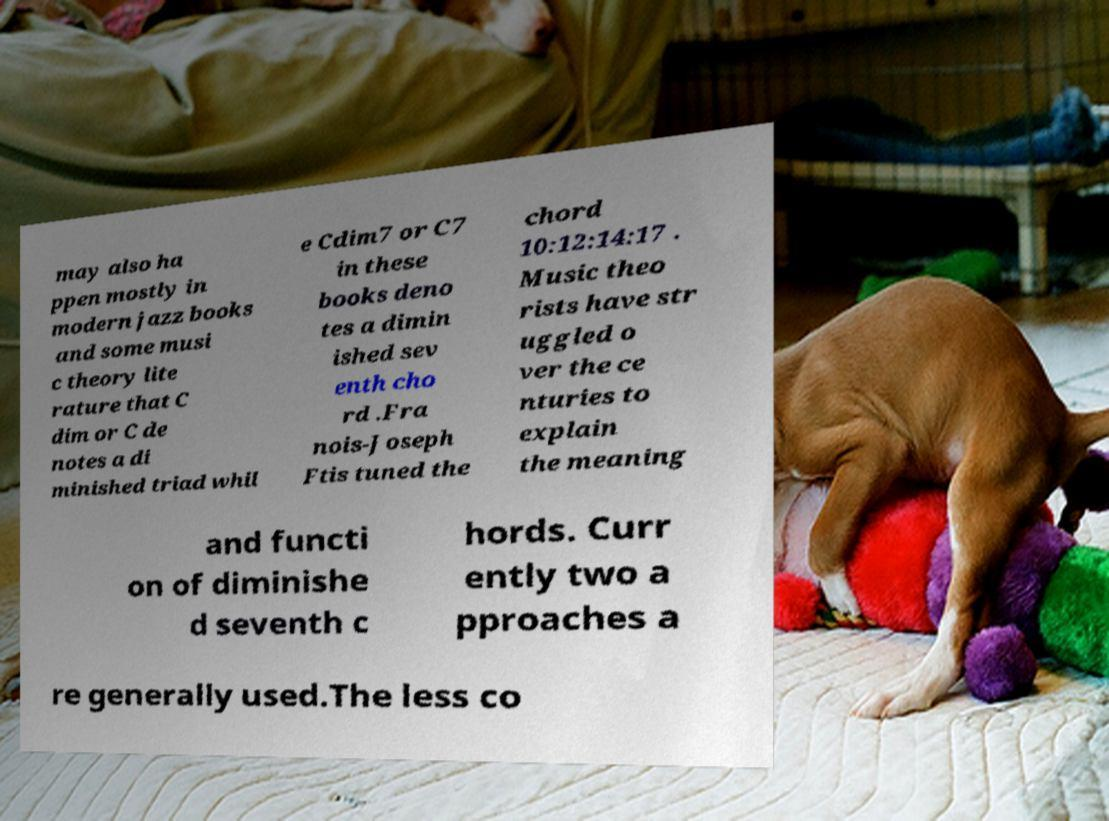Please identify and transcribe the text found in this image. may also ha ppen mostly in modern jazz books and some musi c theory lite rature that C dim or C de notes a di minished triad whil e Cdim7 or C7 in these books deno tes a dimin ished sev enth cho rd .Fra nois-Joseph Ftis tuned the chord 10:12:14:17 . Music theo rists have str uggled o ver the ce nturies to explain the meaning and functi on of diminishe d seventh c hords. Curr ently two a pproaches a re generally used.The less co 